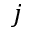<formula> <loc_0><loc_0><loc_500><loc_500>j</formula> 